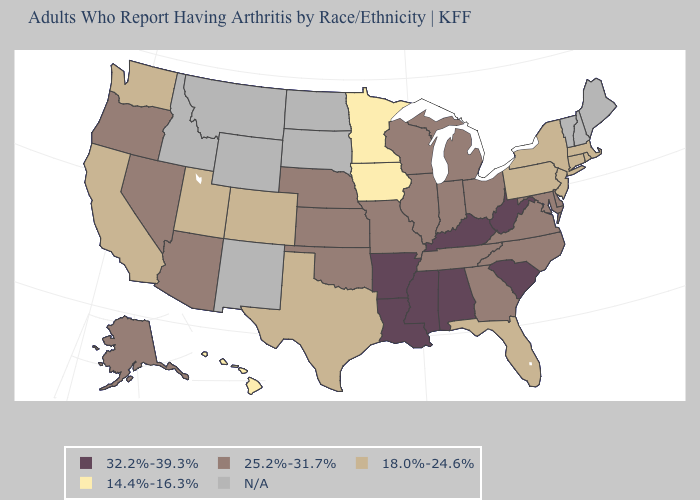What is the lowest value in states that border New Hampshire?
Short answer required. 18.0%-24.6%. What is the highest value in the USA?
Be succinct. 32.2%-39.3%. What is the value of South Dakota?
Write a very short answer. N/A. What is the value of Alabama?
Answer briefly. 32.2%-39.3%. Which states have the lowest value in the Northeast?
Be succinct. Connecticut, Massachusetts, New Jersey, New York, Pennsylvania, Rhode Island. Name the states that have a value in the range 14.4%-16.3%?
Keep it brief. Hawaii, Iowa, Minnesota. What is the value of California?
Be succinct. 18.0%-24.6%. What is the highest value in the Northeast ?
Write a very short answer. 18.0%-24.6%. What is the value of Montana?
Write a very short answer. N/A. What is the value of Minnesota?
Short answer required. 14.4%-16.3%. Name the states that have a value in the range 18.0%-24.6%?
Keep it brief. California, Colorado, Connecticut, Florida, Massachusetts, New Jersey, New York, Pennsylvania, Rhode Island, Texas, Utah, Washington. Is the legend a continuous bar?
Be succinct. No. Does Wisconsin have the highest value in the MidWest?
Give a very brief answer. Yes. Name the states that have a value in the range 18.0%-24.6%?
Quick response, please. California, Colorado, Connecticut, Florida, Massachusetts, New Jersey, New York, Pennsylvania, Rhode Island, Texas, Utah, Washington. What is the value of Hawaii?
Give a very brief answer. 14.4%-16.3%. 